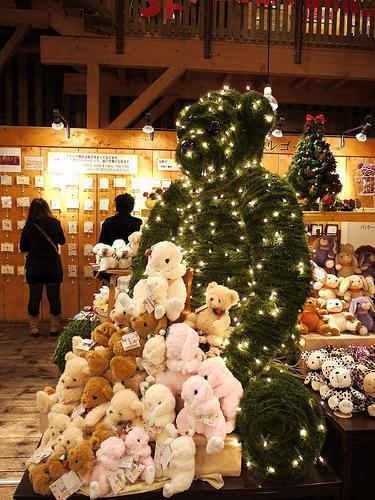How many teddy bears are there?
Give a very brief answer. 3. How many cars on the road?
Give a very brief answer. 0. 